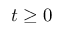Convert formula to latex. <formula><loc_0><loc_0><loc_500><loc_500>t \geq 0</formula> 